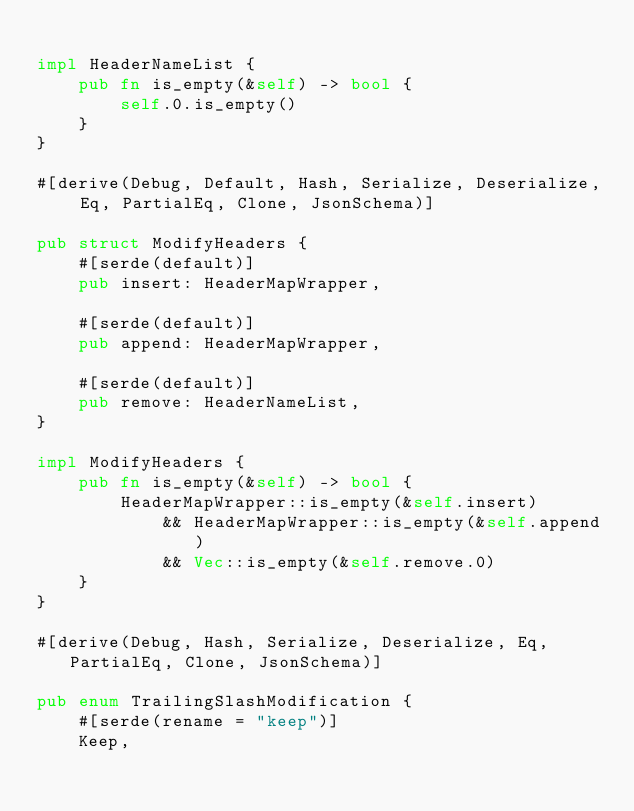<code> <loc_0><loc_0><loc_500><loc_500><_Rust_>
impl HeaderNameList {
    pub fn is_empty(&self) -> bool {
        self.0.is_empty()
    }
}

#[derive(Debug, Default, Hash, Serialize, Deserialize, Eq, PartialEq, Clone, JsonSchema)]

pub struct ModifyHeaders {
    #[serde(default)]
    pub insert: HeaderMapWrapper,

    #[serde(default)]
    pub append: HeaderMapWrapper,

    #[serde(default)]
    pub remove: HeaderNameList,
}

impl ModifyHeaders {
    pub fn is_empty(&self) -> bool {
        HeaderMapWrapper::is_empty(&self.insert)
            && HeaderMapWrapper::is_empty(&self.append)
            && Vec::is_empty(&self.remove.0)
    }
}

#[derive(Debug, Hash, Serialize, Deserialize, Eq, PartialEq, Clone, JsonSchema)]

pub enum TrailingSlashModification {
    #[serde(rename = "keep")]
    Keep,
</code> 